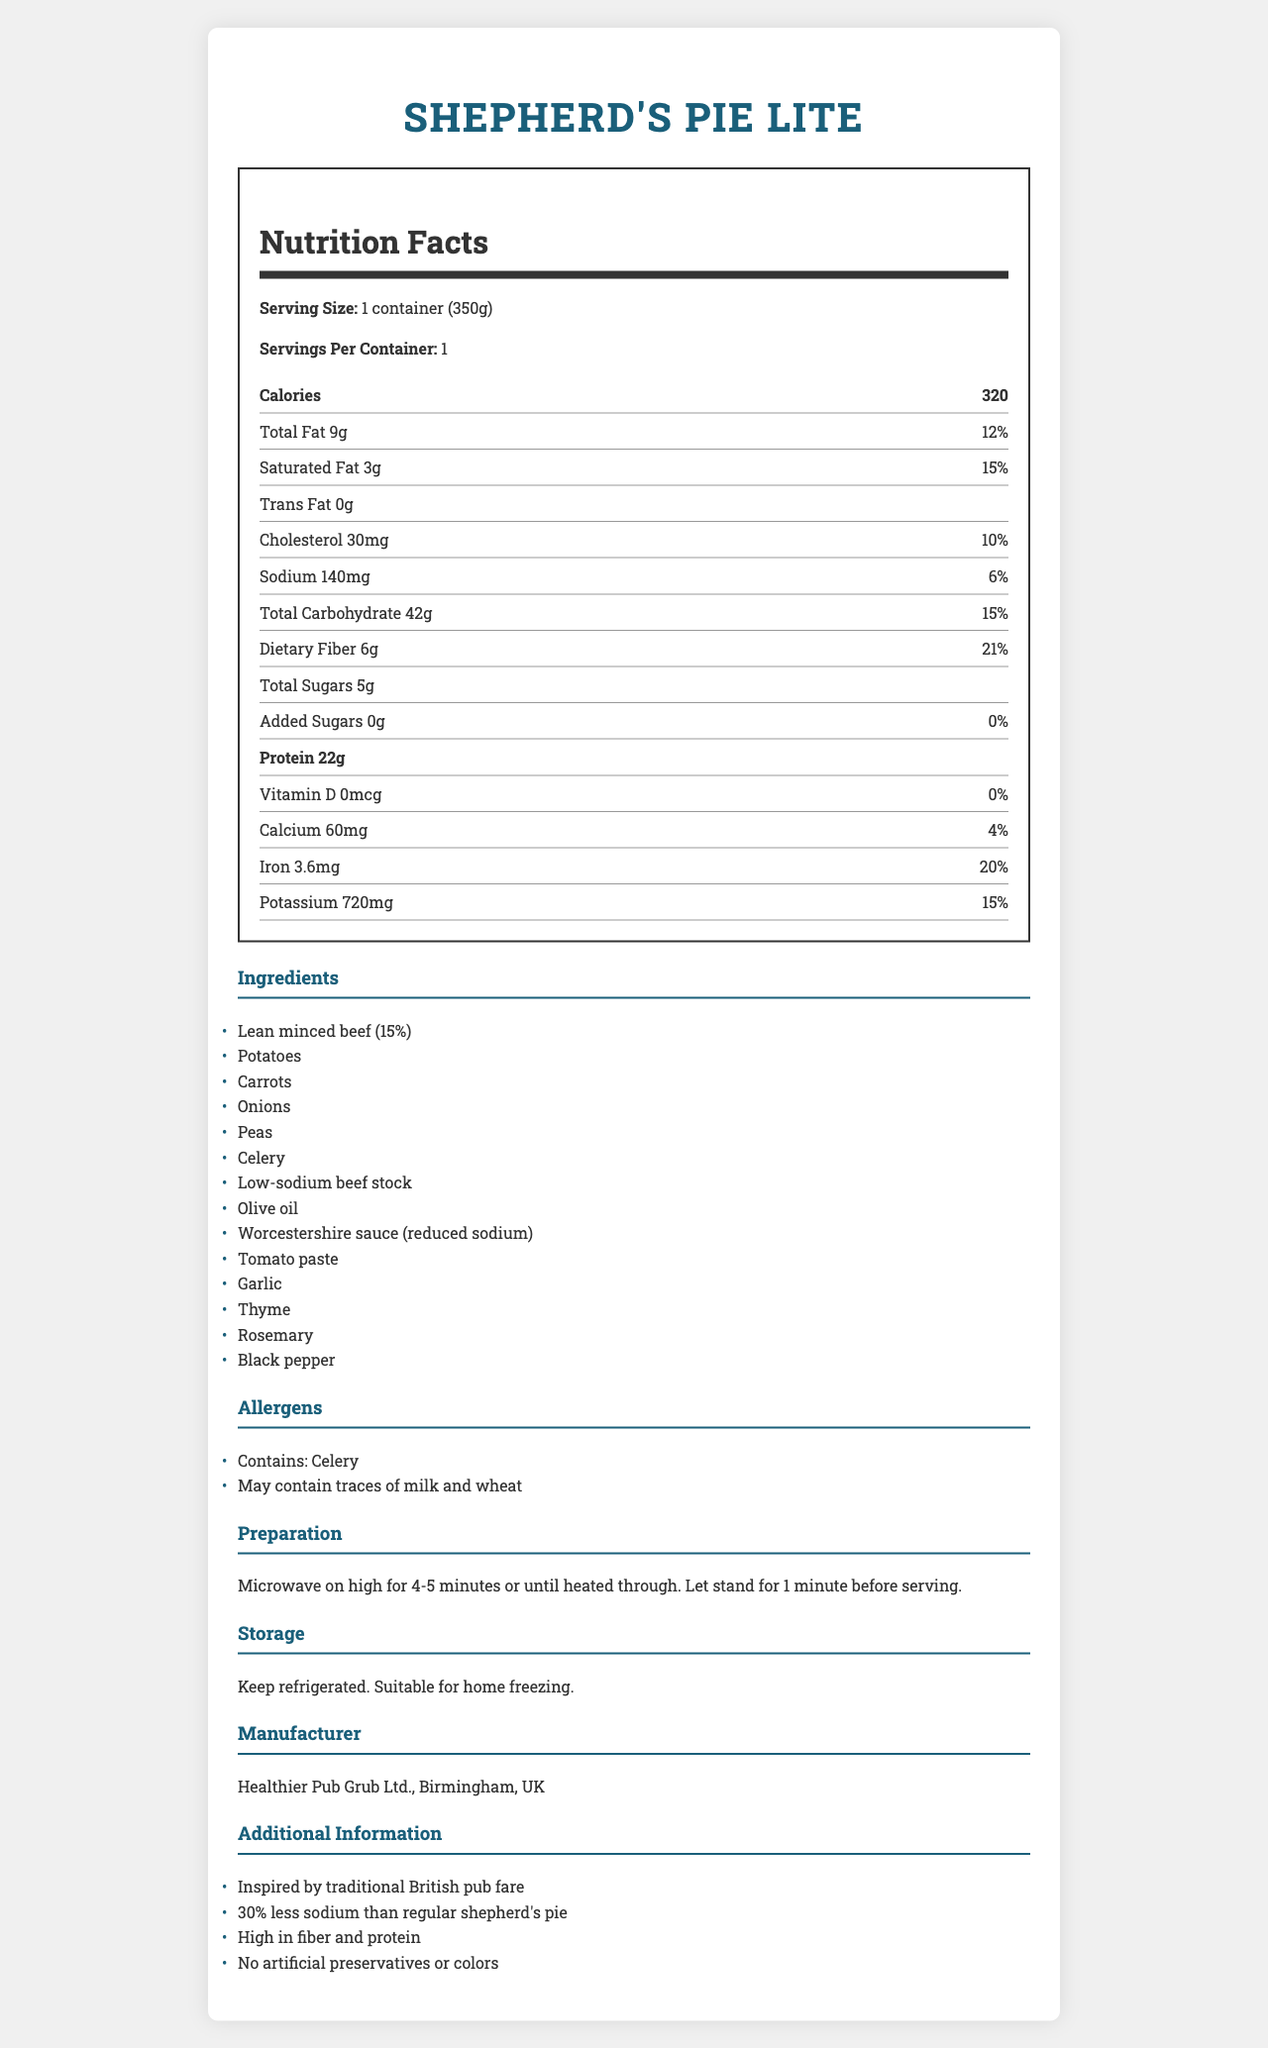What is the serving size for Shepherd's Pie Lite? The serving size is explicitly stated as "1 container (350g)" under the nutrition facts.
Answer: 1 container (350g) How many calories are in a serving of Shepherd's Pie Lite? The calories per serving are listed as 320 in the nutrition facts section.
Answer: 320 What is the total fat content in a serving? The total fat content is shown as "Total Fat 9g" in the nutrition facts.
Answer: 9g How much protein does this meal contain per serving? The protein content per serving is listed as 22g in the nutrition facts.
Answer: 22g Which ingredient is present in the lowest concentration in the Shepherd's Pie Lite? The ingredients are listed in descending order by weight, with black pepper appearing last.
Answer: Black pepper How many grams of dietary fiber are in this ready meal? The dietary fiber content is listed as 6g in the nutrition facts section.
Answer: 6g What allergens are present in Shepherd's Pie Lite? A. Celery B. Milk C. Wheat D. All of the above The document shows that the product "contains: Celery" and "may contain traces of milk and wheat."
Answer: D. All of the above How much potassium does Shepherd's Pie Lite provide? The potassium content is listed as 720mg in the nutrition facts.
Answer: 720mg Which type of fat is absent in this meal? A. Total Fat B. Saturated Fat C. Trans Fat D. Cholesterol The nutrition facts indicate "Trans Fat 0g," meaning it is absent.
Answer: C. Trans Fat Is this meal suitable for vegetarians? The list of ingredients includes "Lean minced beef," making it unsuitable for vegetarians.
Answer: No Does Shepherd's Pie Lite contain any artificial preservatives or colors? The additional information states that the meal contains "No artificial preservatives or colors."
Answer: No Is Shepherd's Pie Lite low in sodium compared to a regular shepherd's pie? The additional information notes "30% less sodium than regular shepherd's pie."
Answer: Yes What is the main idea of the document? The document includes sections on nutrition facts, ingredients, allergens, preparation, storage, manufacturer, and additional health-related benefits.
Answer: It provides detailed nutritional information, ingredient lists, preparation instructions, and additional info for a low-sodium, heart-healthy version of Shepherd's Pie. What is the vitamin D content in Shepherd's Pie Lite? The nutrition facts explicitly state that the vitamin D content is 0mcg.
Answer: 0mcg How should Shepherd's Pie Lite be stored? The storage instructions specify to keep the product refrigerated and that it is suitable for home freezing.
Answer: Keep refrigerated. Suitable for home freezing. Can it be determined if Shepherd's Pie Lite is organic based on the provided information? The document does not provide any information regarding whether the ingredients are organic.
Answer: Not enough information Who manufactures Shepherd's Pie Lite? The manufacturer is listed as "Healthier Pub Grub Ltd., Birmingham, UK" in the manufacturer section.
Answer: Healthier Pub Grub Ltd., Birmingham, UK How much cholesterol does this meal have? The nutrition facts section lists the cholesterol content as 30mg.
Answer: 30mg What percentage of daily iron is provided per serving? The daily value for iron is listed as 20% in the nutrition facts.
Answer: 20% How long should Shepherd's Pie Lite be microwaved? The preparation instructions specify to "Microwave on high for 4-5 minutes or until heated through."
Answer: 4-5 minutes on high 